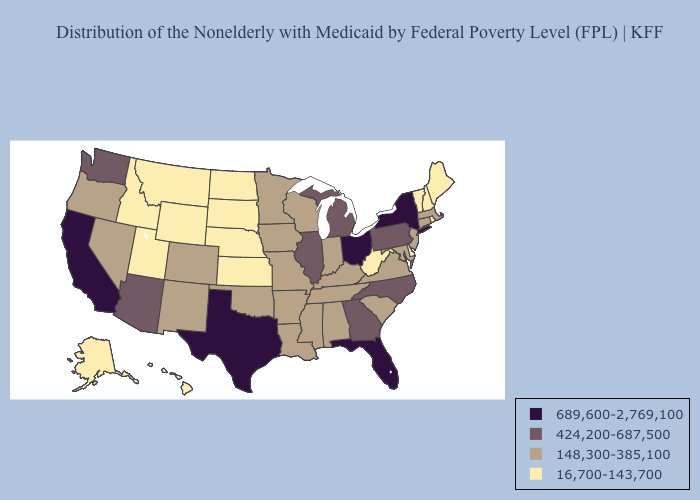Does Missouri have a lower value than Virginia?
Concise answer only. No. What is the value of North Dakota?
Short answer required. 16,700-143,700. Does Louisiana have the lowest value in the South?
Short answer required. No. Name the states that have a value in the range 424,200-687,500?
Be succinct. Arizona, Georgia, Illinois, Michigan, North Carolina, Pennsylvania, Washington. Which states hav the highest value in the MidWest?
Short answer required. Ohio. Among the states that border Washington , which have the highest value?
Give a very brief answer. Oregon. Name the states that have a value in the range 16,700-143,700?
Give a very brief answer. Alaska, Delaware, Hawaii, Idaho, Kansas, Maine, Montana, Nebraska, New Hampshire, North Dakota, Rhode Island, South Dakota, Utah, Vermont, West Virginia, Wyoming. Does California have the highest value in the West?
Give a very brief answer. Yes. Does Massachusetts have a lower value than Vermont?
Write a very short answer. No. Does Virginia have the same value as Kentucky?
Answer briefly. Yes. Name the states that have a value in the range 148,300-385,100?
Give a very brief answer. Alabama, Arkansas, Colorado, Connecticut, Indiana, Iowa, Kentucky, Louisiana, Maryland, Massachusetts, Minnesota, Mississippi, Missouri, Nevada, New Jersey, New Mexico, Oklahoma, Oregon, South Carolina, Tennessee, Virginia, Wisconsin. Name the states that have a value in the range 16,700-143,700?
Answer briefly. Alaska, Delaware, Hawaii, Idaho, Kansas, Maine, Montana, Nebraska, New Hampshire, North Dakota, Rhode Island, South Dakota, Utah, Vermont, West Virginia, Wyoming. Name the states that have a value in the range 148,300-385,100?
Short answer required. Alabama, Arkansas, Colorado, Connecticut, Indiana, Iowa, Kentucky, Louisiana, Maryland, Massachusetts, Minnesota, Mississippi, Missouri, Nevada, New Jersey, New Mexico, Oklahoma, Oregon, South Carolina, Tennessee, Virginia, Wisconsin. Does Florida have the lowest value in the USA?
Answer briefly. No. Does Nebraska have the lowest value in the MidWest?
Short answer required. Yes. 